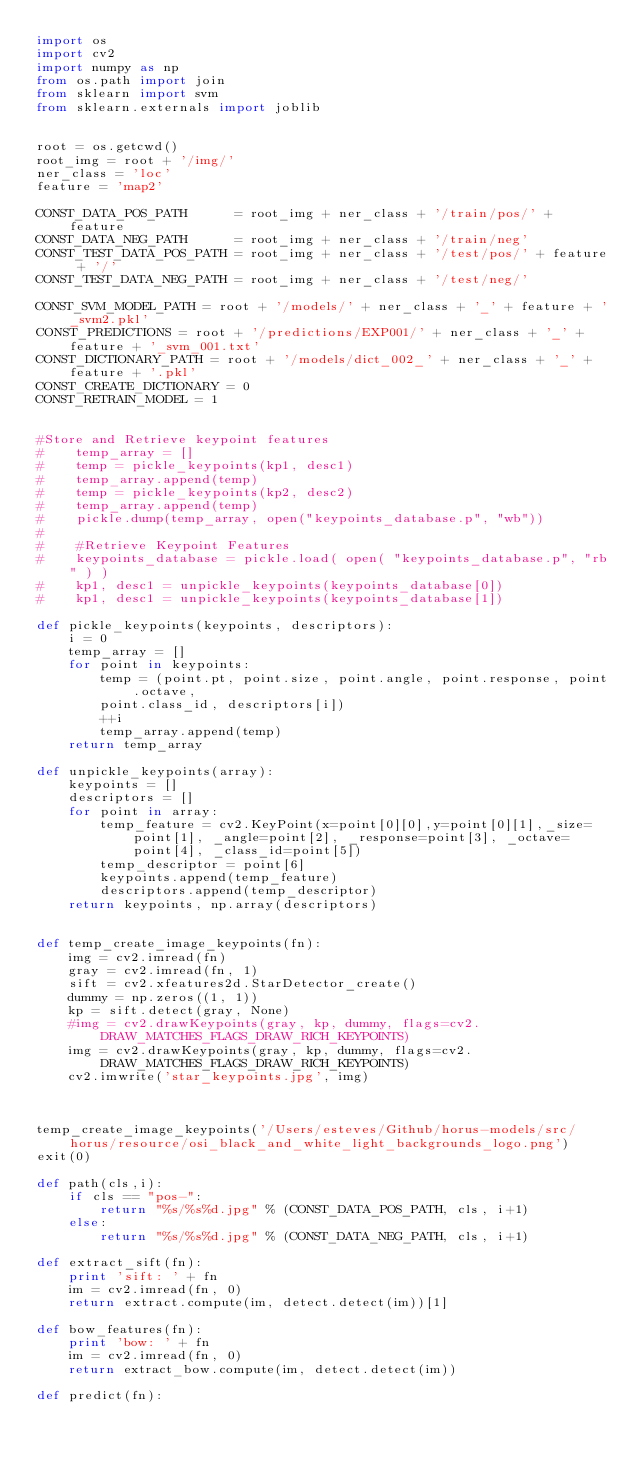<code> <loc_0><loc_0><loc_500><loc_500><_Python_>import os
import cv2
import numpy as np
from os.path import join
from sklearn import svm
from sklearn.externals import joblib


root = os.getcwd()
root_img = root + '/img/'
ner_class = 'loc'
feature = 'map2'

CONST_DATA_POS_PATH      = root_img + ner_class + '/train/pos/' + feature
CONST_DATA_NEG_PATH      = root_img + ner_class + '/train/neg'
CONST_TEST_DATA_POS_PATH = root_img + ner_class + '/test/pos/' + feature + '/'
CONST_TEST_DATA_NEG_PATH = root_img + ner_class + '/test/neg/'

CONST_SVM_MODEL_PATH = root + '/models/' + ner_class + '_' + feature + '_svm2.pkl'
CONST_PREDICTIONS = root + '/predictions/EXP001/' + ner_class + '_' + feature + '_svm_001.txt'
CONST_DICTIONARY_PATH = root + '/models/dict_002_' + ner_class + '_' + feature + '.pkl'
CONST_CREATE_DICTIONARY = 0
CONST_RETRAIN_MODEL = 1


#Store and Retrieve keypoint features
#    temp_array = []
#    temp = pickle_keypoints(kp1, desc1)
#    temp_array.append(temp)
#    temp = pickle_keypoints(kp2, desc2)
#    temp_array.append(temp)
#    pickle.dump(temp_array, open("keypoints_database.p", "wb"))
#
#    #Retrieve Keypoint Features
#    keypoints_database = pickle.load( open( "keypoints_database.p", "rb" ) )
#    kp1, desc1 = unpickle_keypoints(keypoints_database[0])
#    kp1, desc1 = unpickle_keypoints(keypoints_database[1])

def pickle_keypoints(keypoints, descriptors):
    i = 0
    temp_array = []
    for point in keypoints:
        temp = (point.pt, point.size, point.angle, point.response, point.octave,
        point.class_id, descriptors[i])
        ++i
        temp_array.append(temp)
    return temp_array

def unpickle_keypoints(array):
    keypoints = []
    descriptors = []
    for point in array:
        temp_feature = cv2.KeyPoint(x=point[0][0],y=point[0][1],_size=point[1], _angle=point[2], _response=point[3], _octave=point[4], _class_id=point[5])
        temp_descriptor = point[6]
        keypoints.append(temp_feature)
        descriptors.append(temp_descriptor)
    return keypoints, np.array(descriptors)


def temp_create_image_keypoints(fn):
    img = cv2.imread(fn)
    gray = cv2.imread(fn, 1)
    sift = cv2.xfeatures2d.StarDetector_create()
    dummy = np.zeros((1, 1))
    kp = sift.detect(gray, None)
    #img = cv2.drawKeypoints(gray, kp, dummy, flags=cv2.DRAW_MATCHES_FLAGS_DRAW_RICH_KEYPOINTS)
    img = cv2.drawKeypoints(gray, kp, dummy, flags=cv2.DRAW_MATCHES_FLAGS_DRAW_RICH_KEYPOINTS)
    cv2.imwrite('star_keypoints.jpg', img)



temp_create_image_keypoints('/Users/esteves/Github/horus-models/src/horus/resource/osi_black_and_white_light_backgrounds_logo.png')
exit(0)

def path(cls,i):
    if cls == "pos-":
        return "%s/%s%d.jpg" % (CONST_DATA_POS_PATH, cls, i+1)
    else:
        return "%s/%s%d.jpg" % (CONST_DATA_NEG_PATH, cls, i+1)

def extract_sift(fn):
    print 'sift: ' + fn
    im = cv2.imread(fn, 0)
    return extract.compute(im, detect.detect(im))[1]

def bow_features(fn):
    print 'bow: ' + fn
    im = cv2.imread(fn, 0)
    return extract_bow.compute(im, detect.detect(im))

def predict(fn):</code> 